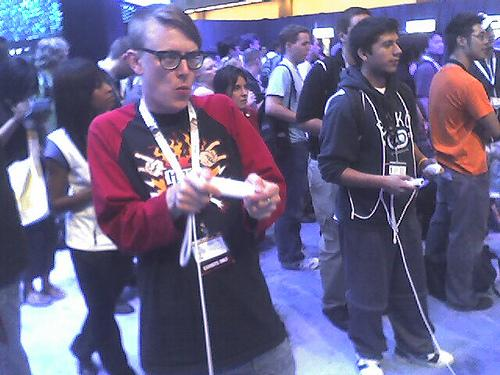What are the people in the front holding?

Choices:
A) controllers
B) puppies
C) umbrellas
D) kittens controllers 